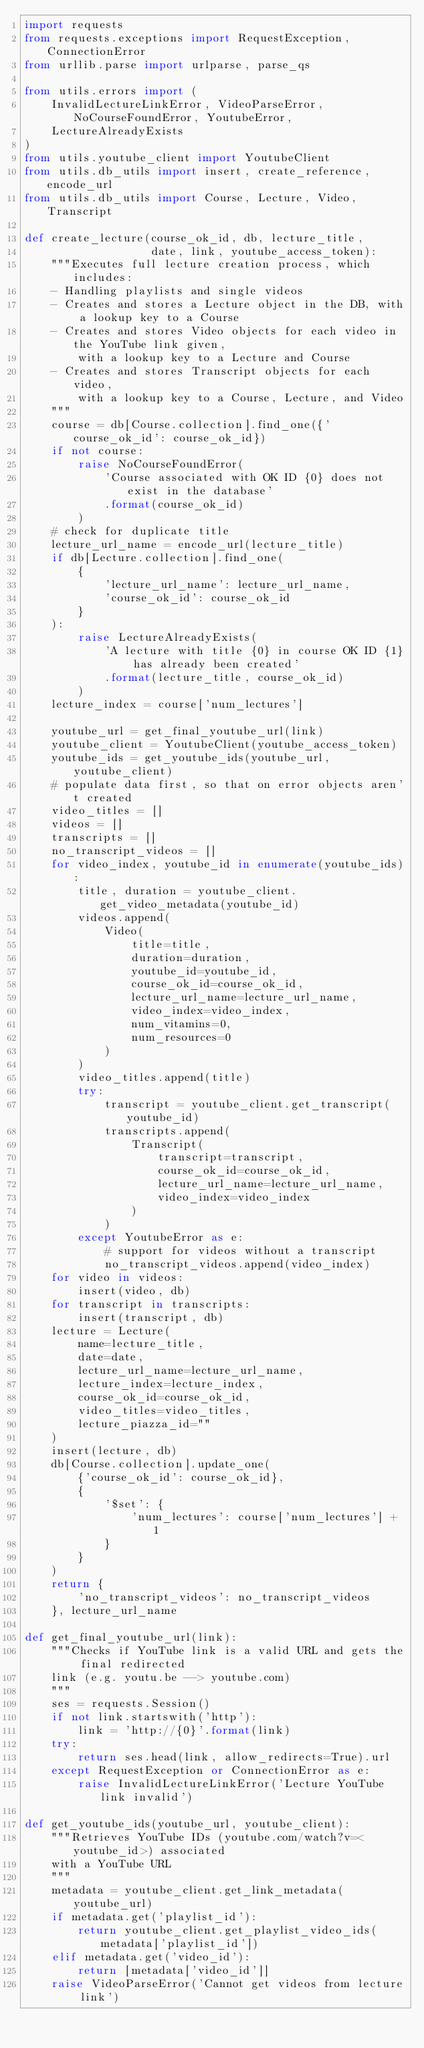<code> <loc_0><loc_0><loc_500><loc_500><_Python_>import requests
from requests.exceptions import RequestException, ConnectionError
from urllib.parse import urlparse, parse_qs

from utils.errors import (
    InvalidLectureLinkError, VideoParseError, NoCourseFoundError, YoutubeError,
    LectureAlreadyExists
)
from utils.youtube_client import YoutubeClient
from utils.db_utils import insert, create_reference, encode_url
from utils.db_utils import Course, Lecture, Video, Transcript

def create_lecture(course_ok_id, db, lecture_title,
                   date, link, youtube_access_token):
    """Executes full lecture creation process, which includes:
    - Handling playlists and single videos
    - Creates and stores a Lecture object in the DB, with a lookup key to a Course
    - Creates and stores Video objects for each video in the YouTube link given,
        with a lookup key to a Lecture and Course
    - Creates and stores Transcript objects for each video,
        with a lookup key to a Course, Lecture, and Video
    """
    course = db[Course.collection].find_one({'course_ok_id': course_ok_id})
    if not course:
        raise NoCourseFoundError(
            'Course associated with OK ID {0} does not exist in the database'
            .format(course_ok_id)
        )
    # check for duplicate title
    lecture_url_name = encode_url(lecture_title)
    if db[Lecture.collection].find_one(
        {
            'lecture_url_name': lecture_url_name,
            'course_ok_id': course_ok_id
        }
    ):
        raise LectureAlreadyExists(
            'A lecture with title {0} in course OK ID {1} has already been created'
            .format(lecture_title, course_ok_id)
        )
    lecture_index = course['num_lectures']

    youtube_url = get_final_youtube_url(link)
    youtube_client = YoutubeClient(youtube_access_token)
    youtube_ids = get_youtube_ids(youtube_url, youtube_client)
    # populate data first, so that on error objects aren't created
    video_titles = []
    videos = []
    transcripts = []
    no_transcript_videos = []
    for video_index, youtube_id in enumerate(youtube_ids):
        title, duration = youtube_client.get_video_metadata(youtube_id)
        videos.append(
            Video(
                title=title,
                duration=duration,
                youtube_id=youtube_id,
                course_ok_id=course_ok_id,
                lecture_url_name=lecture_url_name,
                video_index=video_index,
                num_vitamins=0,
                num_resources=0
            )
        )
        video_titles.append(title)
        try:
            transcript = youtube_client.get_transcript(youtube_id)
            transcripts.append(
                Transcript(
                    transcript=transcript,
                    course_ok_id=course_ok_id,
                    lecture_url_name=lecture_url_name,
                    video_index=video_index
                )
            )
        except YoutubeError as e:
            # support for videos without a transcript
            no_transcript_videos.append(video_index)
    for video in videos:
        insert(video, db)
    for transcript in transcripts:
        insert(transcript, db)
    lecture = Lecture(
        name=lecture_title,
        date=date,
        lecture_url_name=lecture_url_name,
        lecture_index=lecture_index,
        course_ok_id=course_ok_id,
        video_titles=video_titles,
        lecture_piazza_id=""
    )
    insert(lecture, db)
    db[Course.collection].update_one(
        {'course_ok_id': course_ok_id},
        {
            '$set': {
                'num_lectures': course['num_lectures'] + 1
            }
        }
    )
    return {
        'no_transcript_videos': no_transcript_videos
    }, lecture_url_name

def get_final_youtube_url(link):
    """Checks if YouTube link is a valid URL and gets the final redirected
    link (e.g. youtu.be --> youtube.com)
    """
    ses = requests.Session()
    if not link.startswith('http'):
        link = 'http://{0}'.format(link)
    try:
        return ses.head(link, allow_redirects=True).url
    except RequestException or ConnectionError as e:
        raise InvalidLectureLinkError('Lecture YouTube link invalid')

def get_youtube_ids(youtube_url, youtube_client):
    """Retrieves YouTube IDs (youtube.com/watch?v=<youtube_id>) associated
    with a YouTube URL
    """
    metadata = youtube_client.get_link_metadata(youtube_url)
    if metadata.get('playlist_id'):
        return youtube_client.get_playlist_video_ids(metadata['playlist_id'])
    elif metadata.get('video_id'):
        return [metadata['video_id']]
    raise VideoParseError('Cannot get videos from lecture link')
</code> 